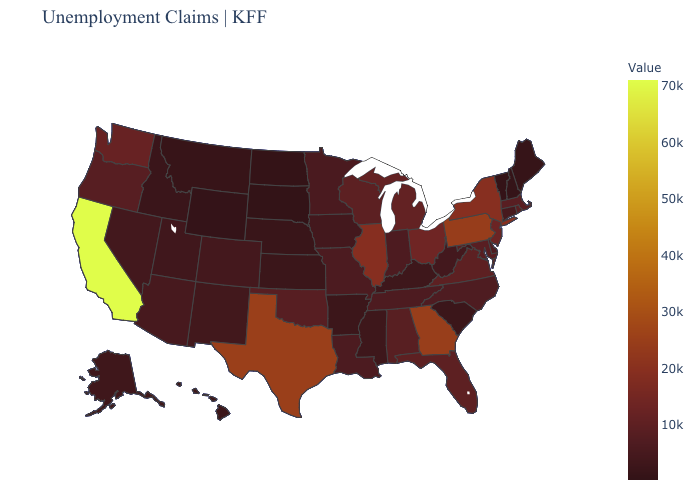Does Mississippi have the highest value in the USA?
Write a very short answer. No. 